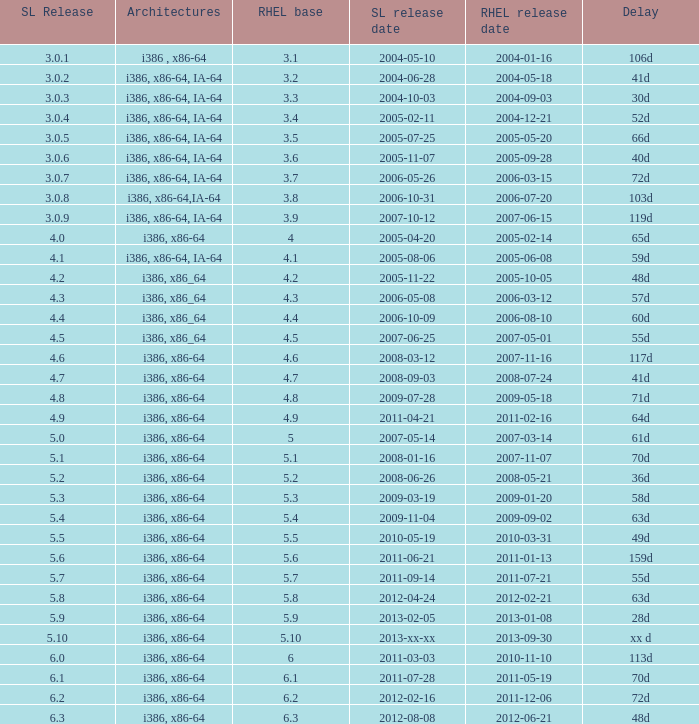Name the delay when scientific linux release is 5.10 Xx d. 